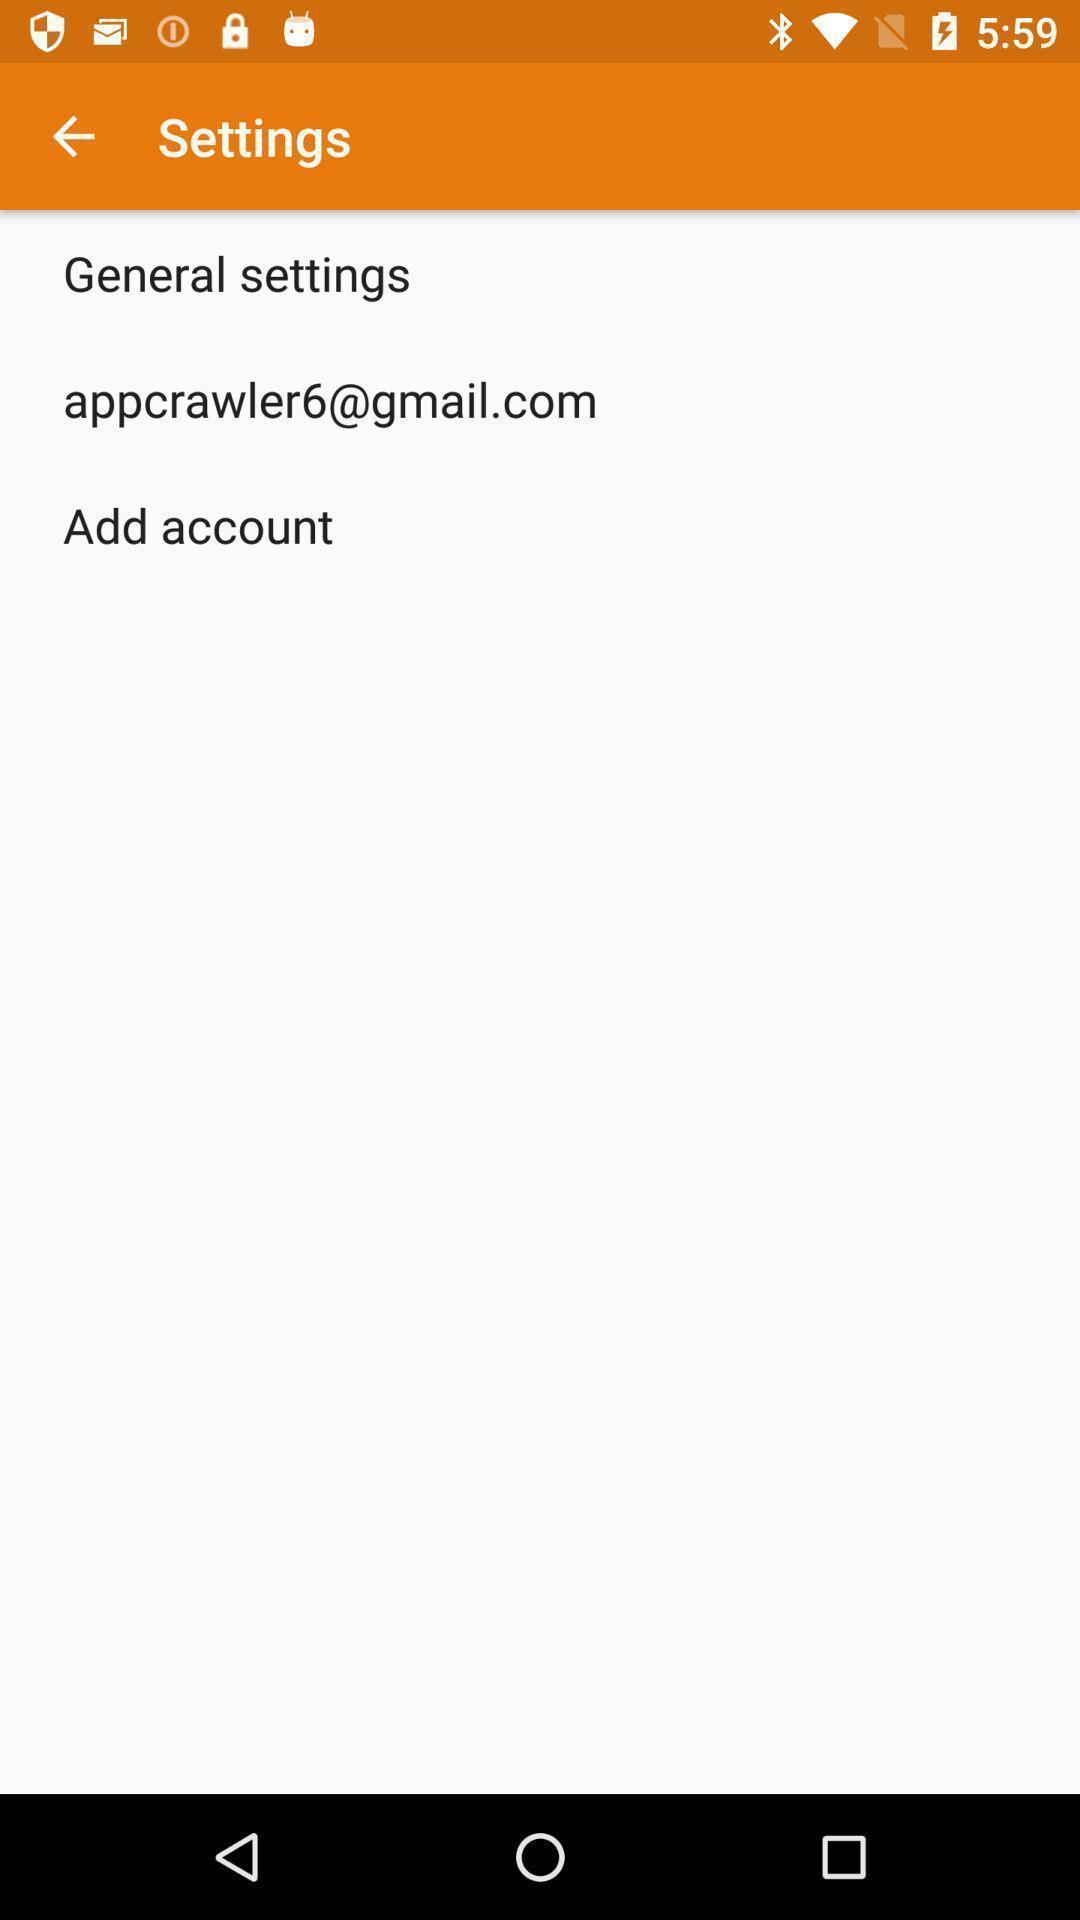Describe the visual elements of this screenshot. Settings page displayed. 